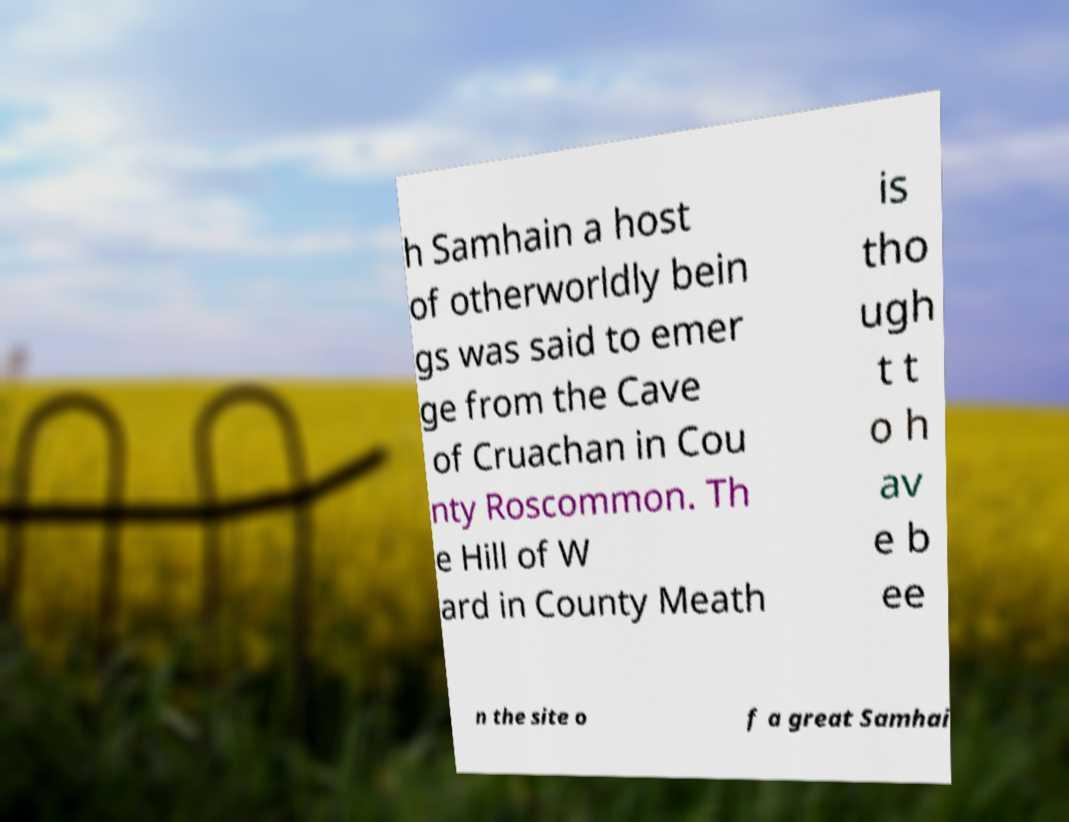Please identify and transcribe the text found in this image. h Samhain a host of otherworldly bein gs was said to emer ge from the Cave of Cruachan in Cou nty Roscommon. Th e Hill of W ard in County Meath is tho ugh t t o h av e b ee n the site o f a great Samhai 